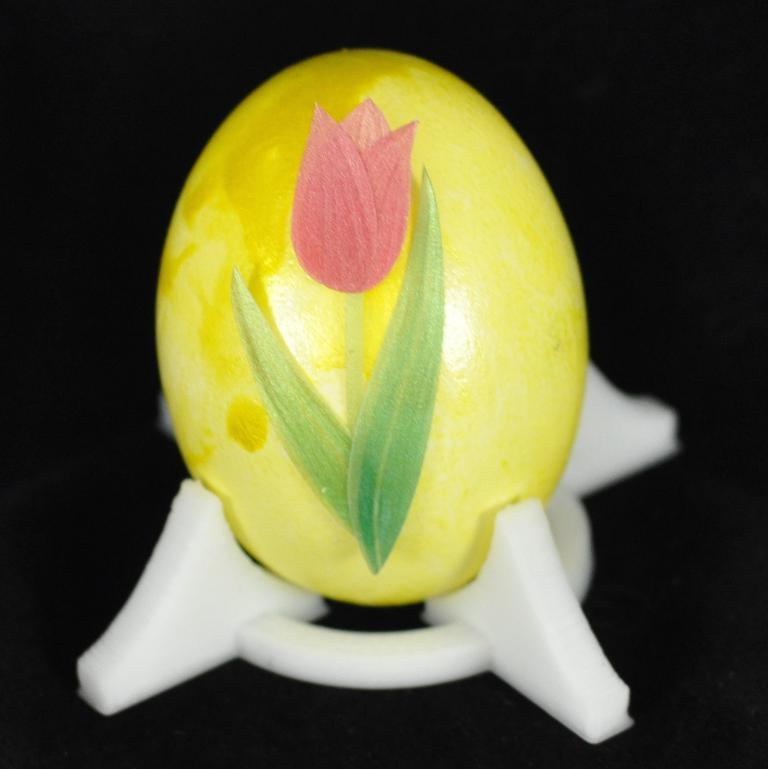What is depicted in the painting that is visible in the image? There is a painting of a flower in the image. What color is the object on which the painting is placed? The painting is on a yellow-colored object. How is the yellow-colored object supported in the image? The yellow-colored object is on a stand. What color is the background of the image? The background of the image is black in color. What type of advertisement can be seen in the image? There is no advertisement present in the image; it features a painting of a flower on a yellow-colored object. How many dogs are visible in the image? There are no dogs present in the image. 